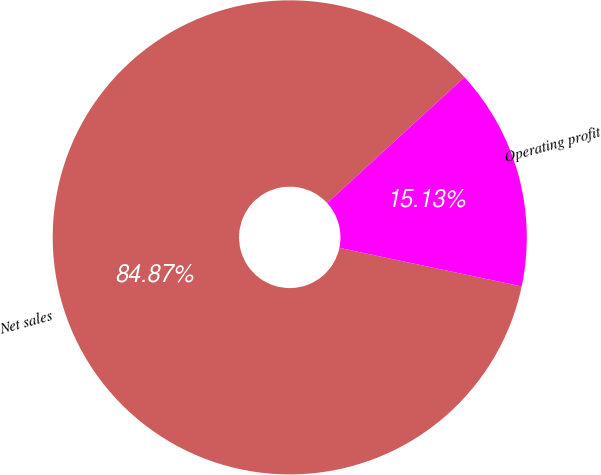<chart> <loc_0><loc_0><loc_500><loc_500><pie_chart><fcel>Net sales<fcel>Operating profit<nl><fcel>84.87%<fcel>15.13%<nl></chart> 